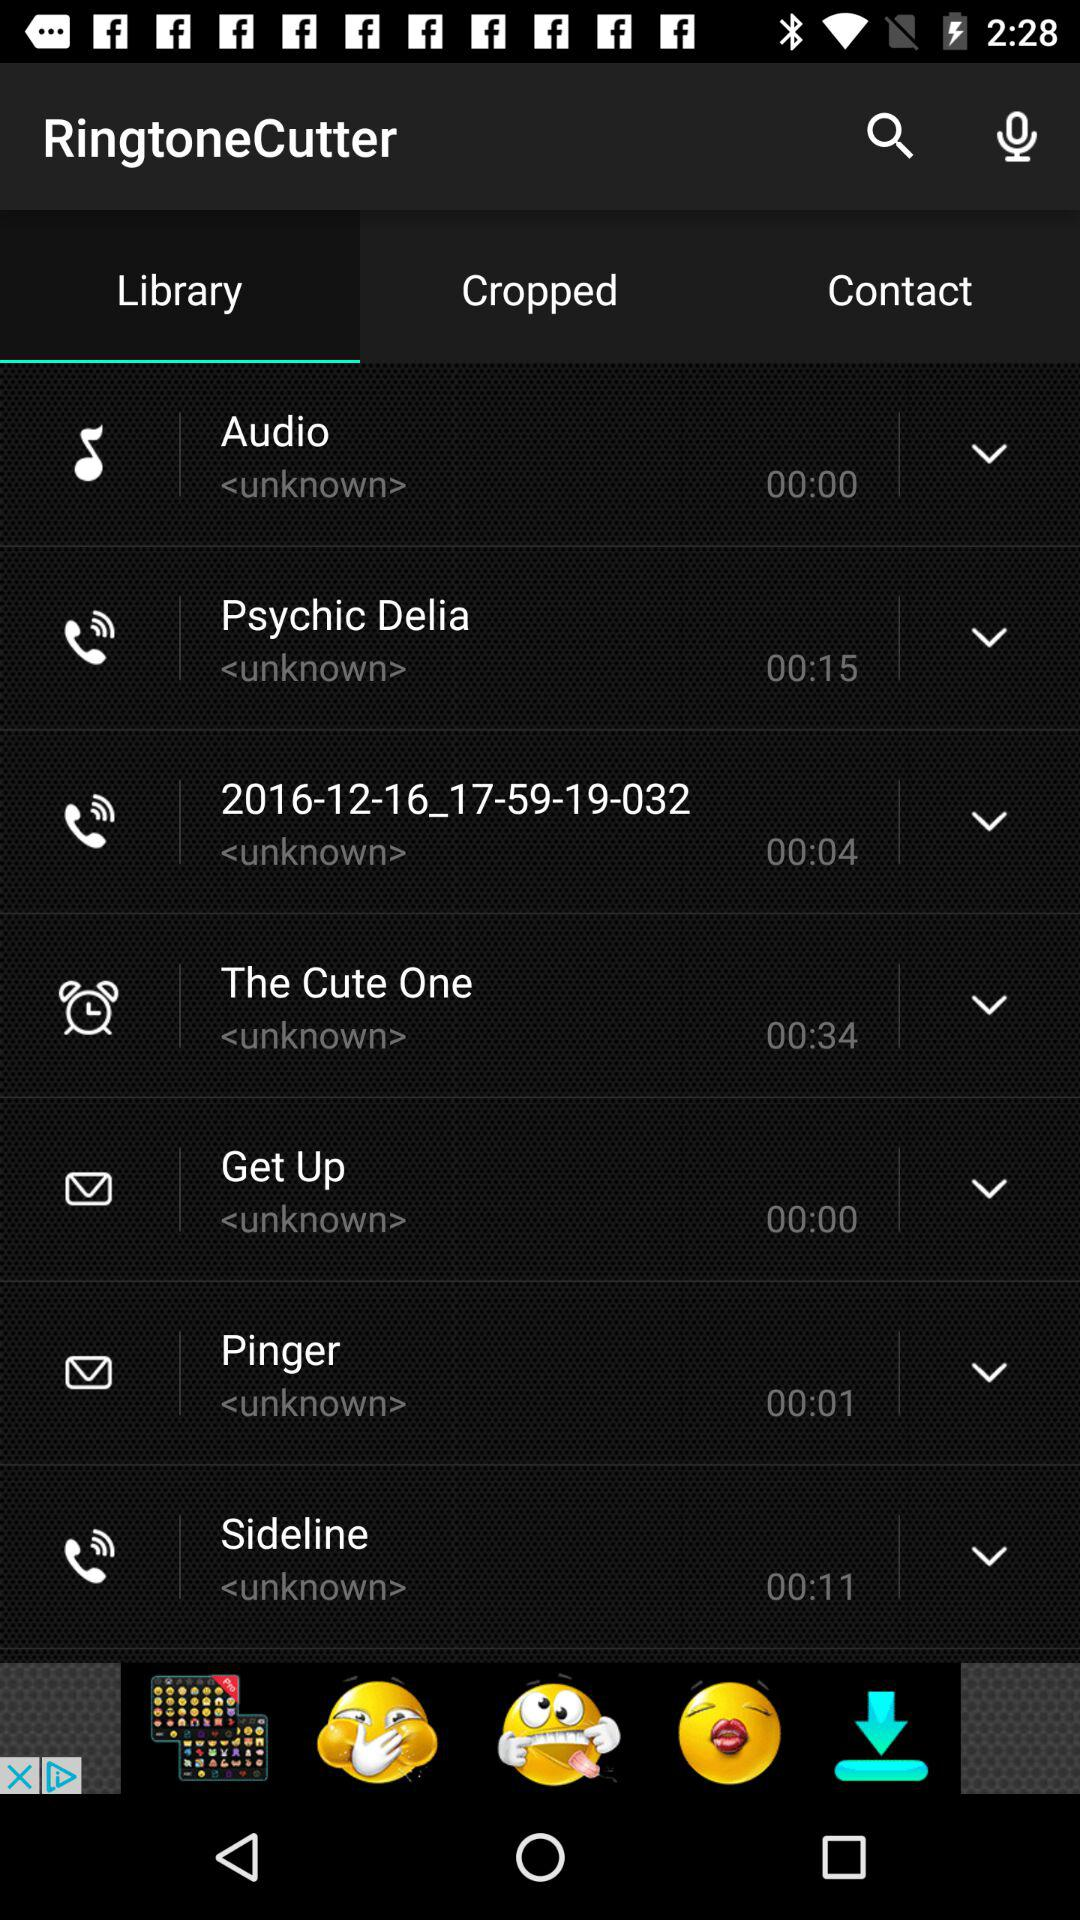Which is the selected tab in the "RingtoneCutter"? The selected tab is "Library". 